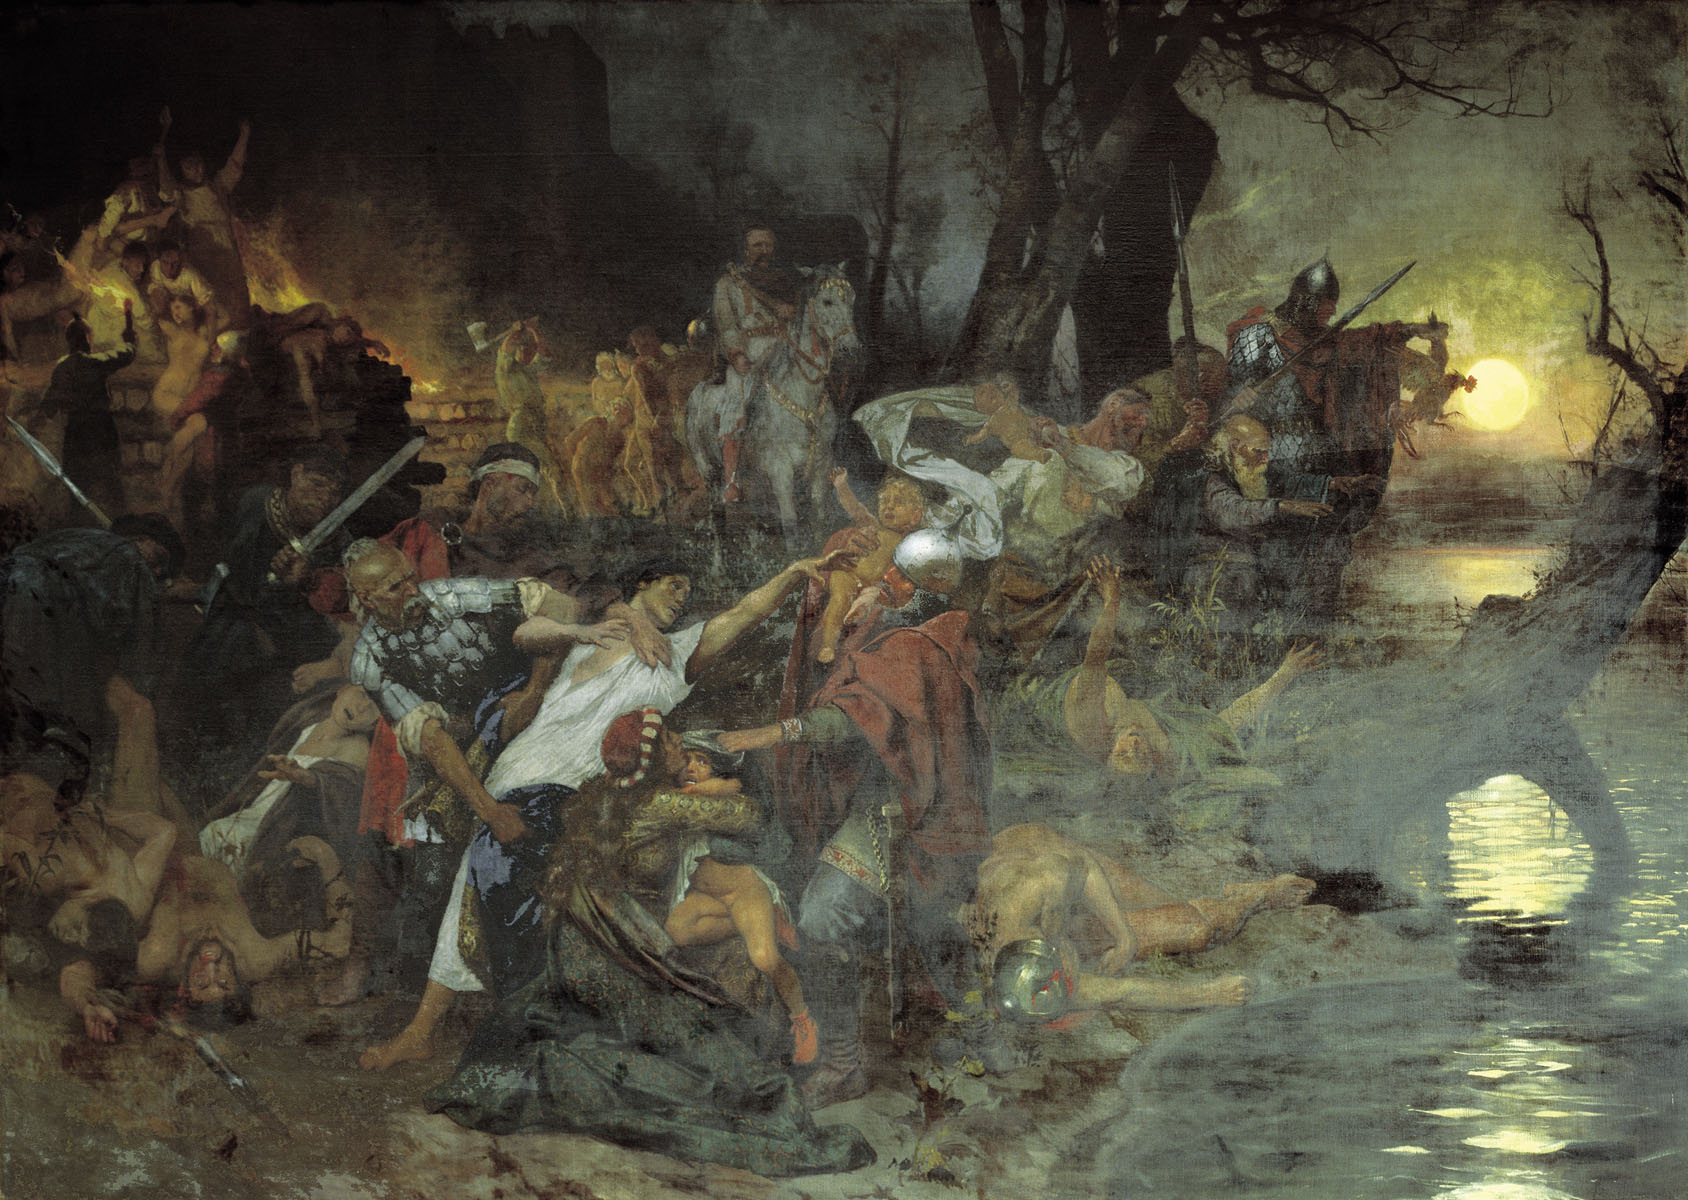What do you see happening in this image? The image depicts a vivid and stormy battle scene, set under a melancholic moonlit sky that highlights the turmoil. The painting is executed in the Romantic style, evident from the dramatic use of dark and moody tones juxtaposed with the bright moon, which casts a ghostly glow over the chaotic scene. The figures are entangled in fierce combat within a swampy landscape, with visible weapons like swords and spears suggesting a historic or medieval setting. The artist employs a masterful composition to evoke the intensity of the conflict and the tragedy of the battlefield, while ruins and twisted trees in the backdrop emphasize the disruption of peace. This painting could be interpreted as a powerful allegory of human strife and conflict, leaving viewers to ponder the deeper stories behind this ferocious encounter. 